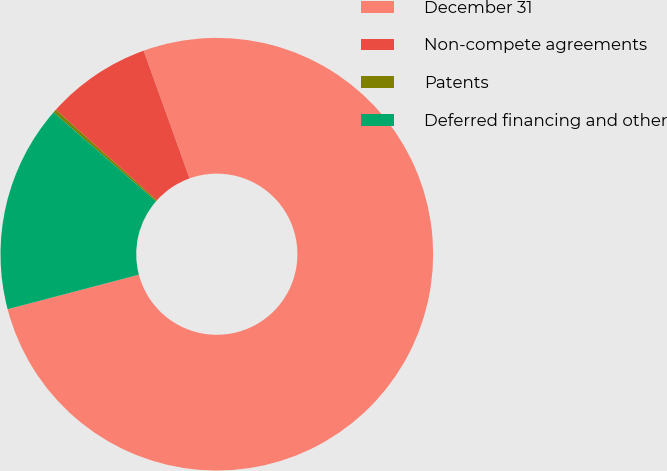Convert chart to OTSL. <chart><loc_0><loc_0><loc_500><loc_500><pie_chart><fcel>December 31<fcel>Non-compete agreements<fcel>Patents<fcel>Deferred financing and other<nl><fcel>76.4%<fcel>7.87%<fcel>0.25%<fcel>15.48%<nl></chart> 